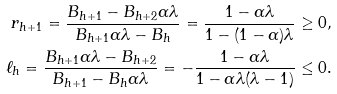<formula> <loc_0><loc_0><loc_500><loc_500>r _ { h + 1 } = \frac { B _ { h + 1 } - B _ { h + 2 } \alpha \lambda } { B _ { h + 1 } \alpha \lambda - B _ { h } } = \frac { 1 - \alpha \lambda } { 1 - ( 1 - \alpha ) \lambda } \geq 0 , \\ \ell _ { h } = \frac { B _ { h + 1 } \alpha \lambda - B _ { h + 2 } } { B _ { h + 1 } - B _ { h } \alpha \lambda } = - \frac { 1 - \alpha \lambda } { 1 - \alpha \lambda ( \lambda - 1 ) } \leq 0 .</formula> 